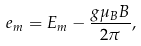<formula> <loc_0><loc_0><loc_500><loc_500>e _ { m } = E _ { m } - \frac { g \mu _ { B } B } { 2 \pi } ,</formula> 